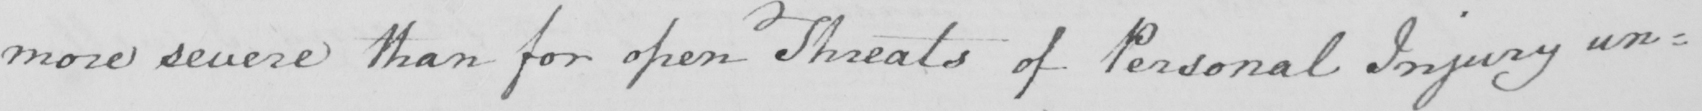What does this handwritten line say? more severe than for open Threats of Personal Injury un : 